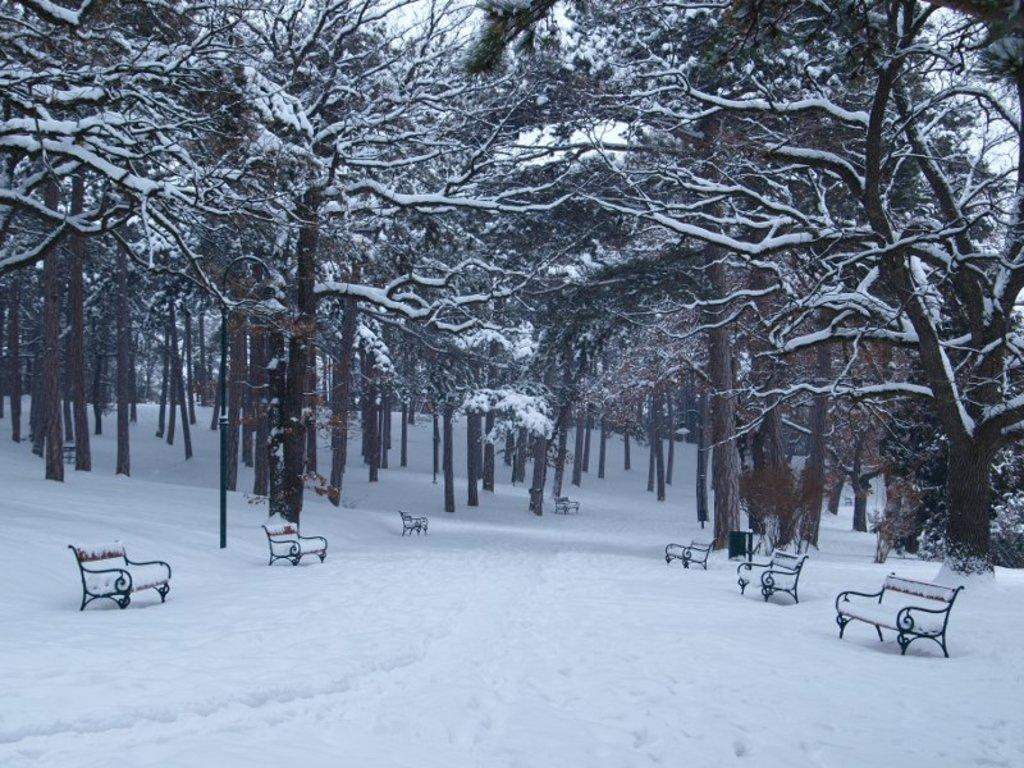What type of weather is depicted in the image? There is snow on the ground in the image, indicating a winter scene. What objects are present on the snow? There are benches on the snow. What type of vegetation is visible in the image? There are trees in the image. How is the snow affecting the trees in the image? Snow is present on the trees. What can be seen in the background of the image? The sky is visible in the background of the image. How many waves can be seen crashing on the shore in the image? There are no waves present in the image, as it depicts a snowy scene with trees and benches. What type of legal advice is the lawyer providing in the image? There is no lawyer present in the image; it features a snowy scene with trees and benches. 